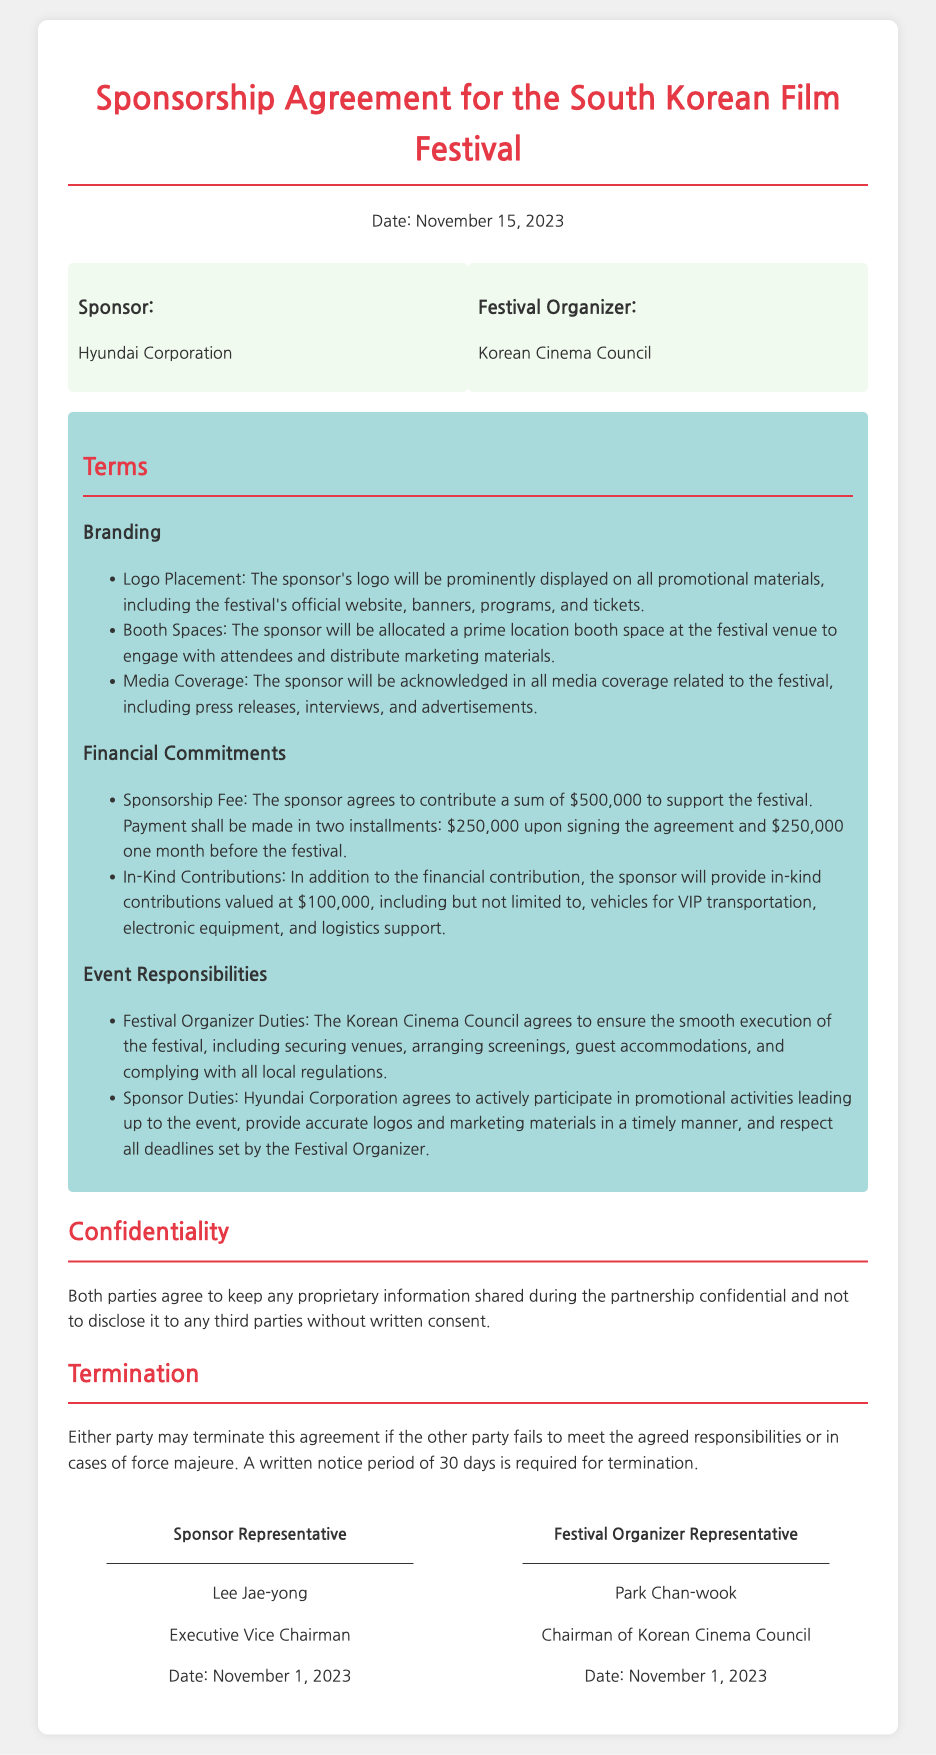what is the date of the agreement? The date of the agreement is mentioned at the beginning of the document.
Answer: November 15, 2023 who is the sponsor? The sponsor is identified in the parties section of the document.
Answer: Hyundai Corporation how much is the sponsorship fee? The sponsorship fee is specified under Financial Commitments.
Answer: $500,000 who represents the festival organizer? The representative of the festival organizer is stated under the signature section.
Answer: Park Chan-wook what is the value of in-kind contributions? The value of in-kind contributions is stated in the Financial Commitments section.
Answer: $100,000 what is the required notice period for termination? The notice period for termination is specified in the Termination section.
Answer: 30 days where will the sponsor's logo be displayed? The placement of the sponsor's logo is mentioned in the Branding section.
Answer: Promotional materials what are the sponsor's duties? The sponsor's duties are outlined in the Event Responsibilities section.
Answer: Participate in promotional activities what organization is responsible for ensuring smooth execution of the festival? The organization responsible for the festival's execution is mentioned in Event Responsibilities.
Answer: Korean Cinema Council what is the name of the festival organizer? The festival organizer is named in the parties section.
Answer: Korean Cinema Council 